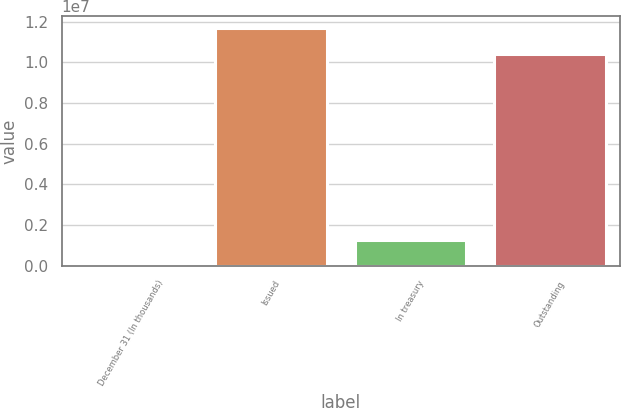Convert chart. <chart><loc_0><loc_0><loc_500><loc_500><bar_chart><fcel>December 31 (In thousands)<fcel>Issued<fcel>In treasury<fcel>Outstanding<nl><fcel>2012<fcel>1.16938e+07<fcel>1.28822e+06<fcel>1.04056e+07<nl></chart> 